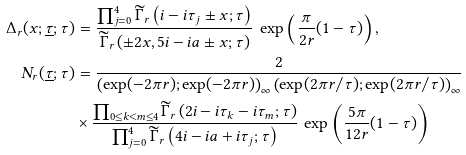<formula> <loc_0><loc_0><loc_500><loc_500>\Delta _ { r } ( x ; \underline { \tau } ; \tau ) & = \frac { \prod _ { j = 0 } ^ { 4 } \widetilde { \Gamma } _ { r } \left ( i - i \tau _ { j } \pm x ; \tau \right ) } { \widetilde { \Gamma } _ { r } \left ( \pm 2 x , 5 i - i a \pm x ; \tau \right ) } \, \exp \left ( \frac { \pi } { 2 r } ( 1 - \tau ) \right ) , \\ N _ { r } ( \underline { \tau } ; \tau ) & = \frac { 2 } { \left ( \exp ( - 2 \pi r ) ; \exp ( - 2 \pi r ) \right ) _ { \infty } \left ( \exp ( 2 \pi r / \tau ) ; \exp ( 2 \pi r / \tau ) \right ) _ { \infty } } \\ & \times \frac { \prod _ { 0 \leq k < m \leq 4 } \widetilde { \Gamma } _ { r } \left ( 2 i - i \tau _ { k } - i \tau _ { m } ; \tau \right ) } { \prod _ { j = 0 } ^ { 4 } \widetilde { \Gamma } _ { r } \left ( 4 i - i a + i \tau _ { j } ; \tau \right ) } \, \exp \left ( \frac { 5 \pi } { 1 2 r } ( 1 - \tau ) \right )</formula> 